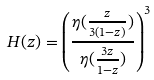Convert formula to latex. <formula><loc_0><loc_0><loc_500><loc_500>H ( z ) = \left ( \frac { \eta ( \frac { z } { 3 ( 1 - z ) } ) } { \eta ( \frac { 3 z } { 1 - z } ) } \right ) ^ { 3 }</formula> 